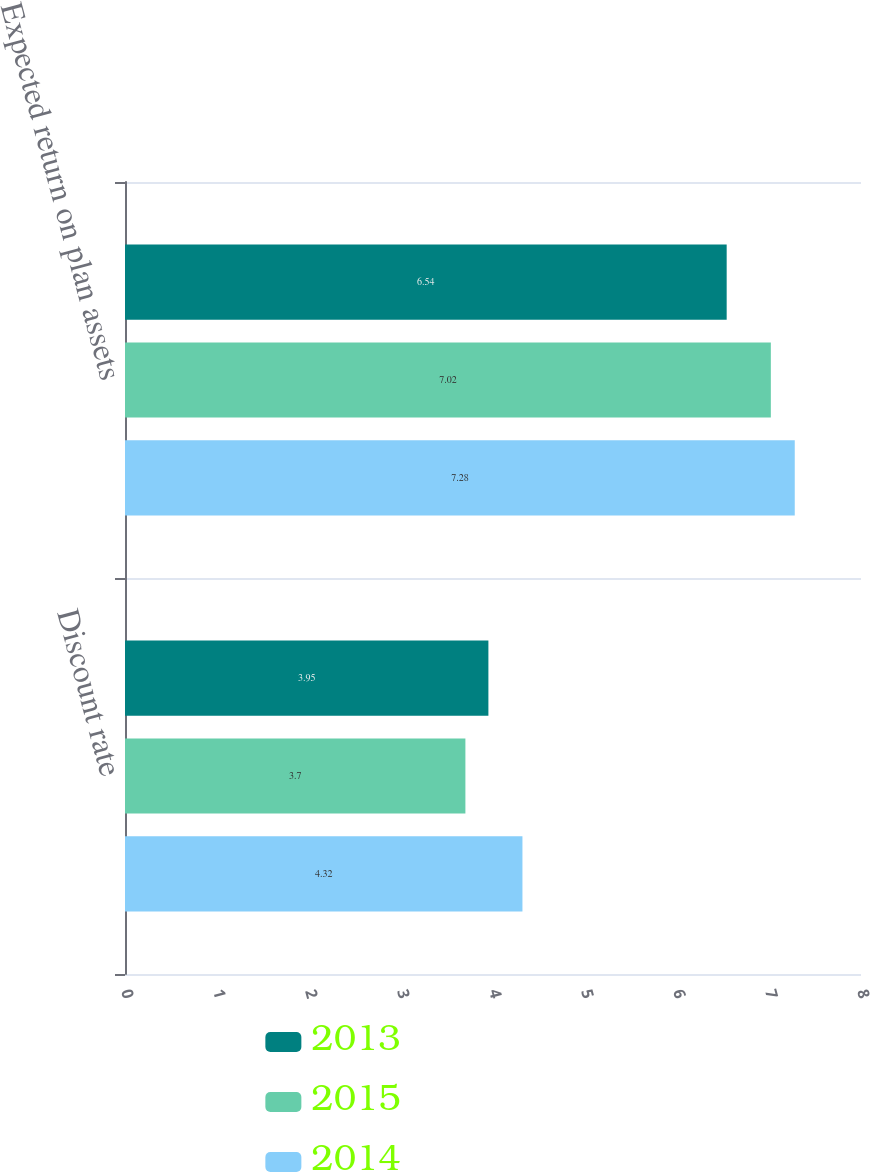<chart> <loc_0><loc_0><loc_500><loc_500><stacked_bar_chart><ecel><fcel>Discount rate<fcel>Expected return on plan assets<nl><fcel>2013<fcel>3.95<fcel>6.54<nl><fcel>2015<fcel>3.7<fcel>7.02<nl><fcel>2014<fcel>4.32<fcel>7.28<nl></chart> 